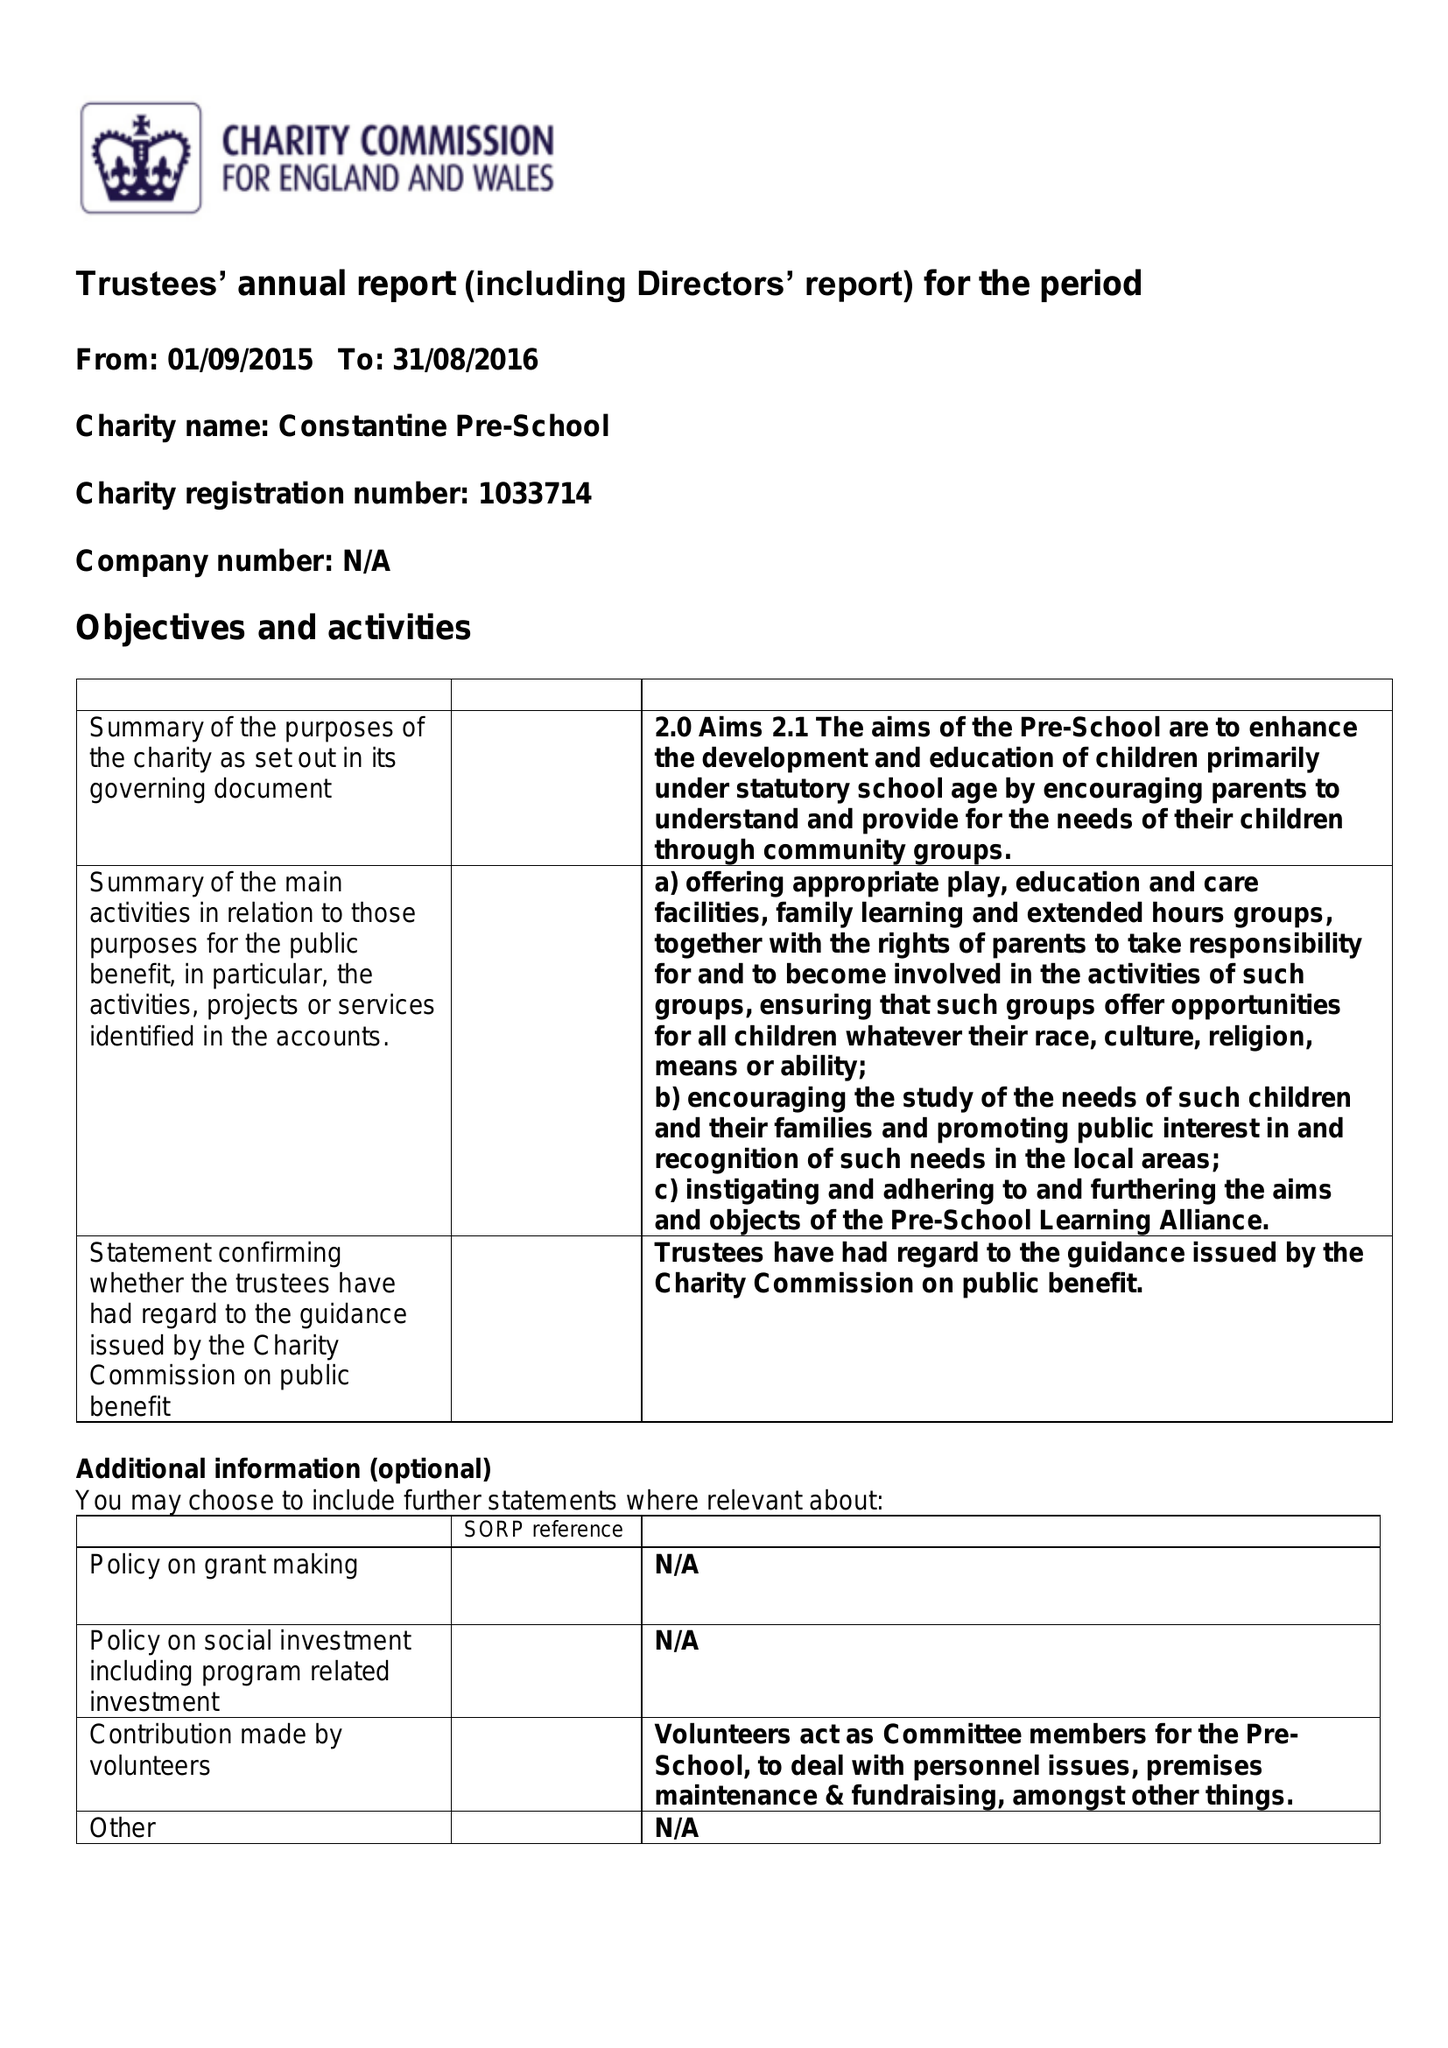What is the value for the spending_annually_in_british_pounds?
Answer the question using a single word or phrase. 54374.00 